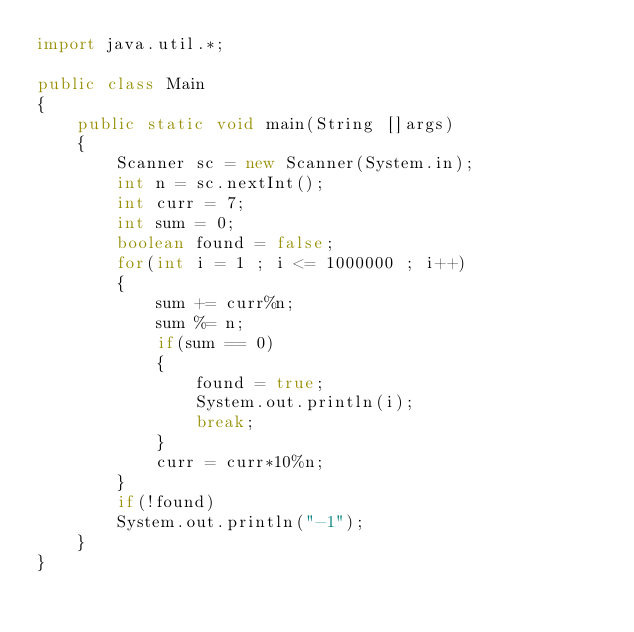Convert code to text. <code><loc_0><loc_0><loc_500><loc_500><_Java_>import java.util.*;
 
public class Main
{
    public static void main(String []args)
    {
        Scanner sc = new Scanner(System.in);
        int n = sc.nextInt();
        int curr = 7;
        int sum = 0;
        boolean found = false;
        for(int i = 1 ; i <= 1000000 ; i++)
        {
            sum += curr%n;
            sum %= n;
            if(sum == 0)
            {
                found = true;
                System.out.println(i);
                break;
            }
            curr = curr*10%n;
        }
        if(!found)
        System.out.println("-1");
    }
}</code> 